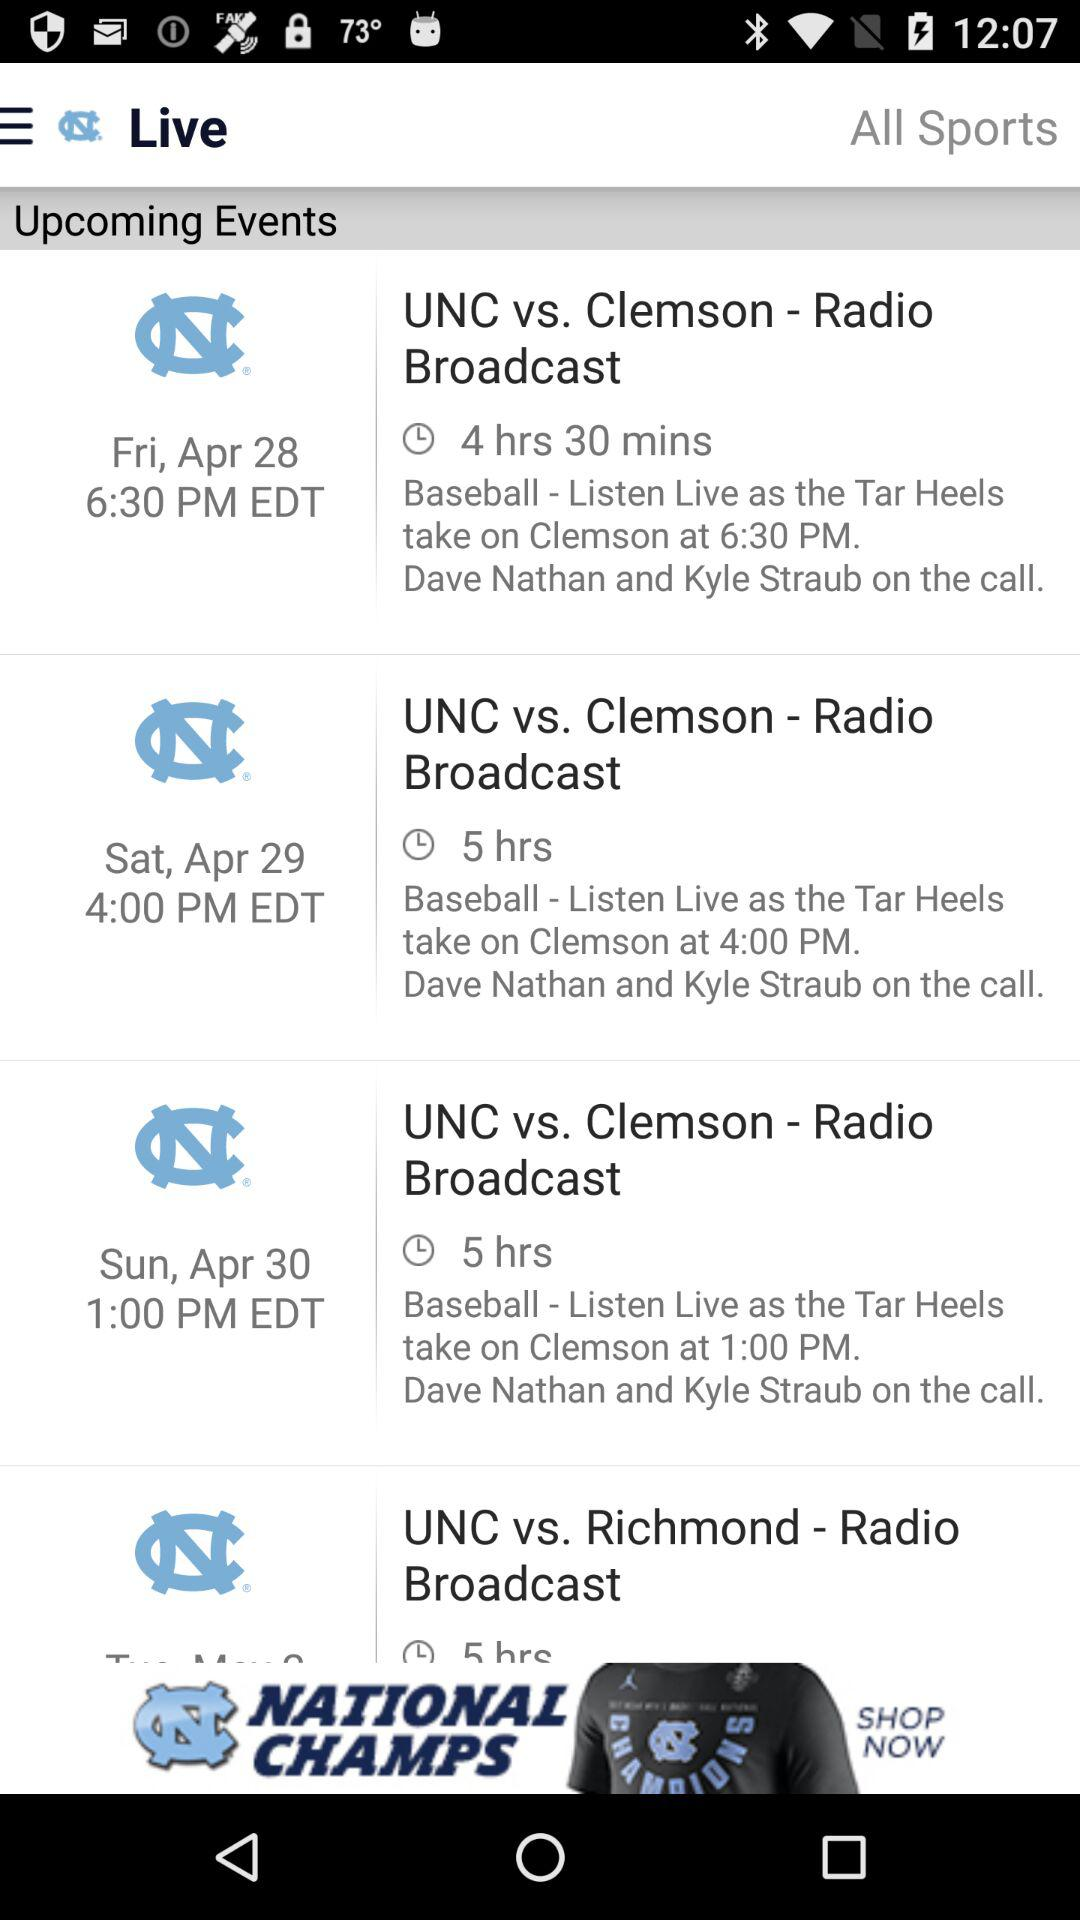What is the duration of the upcoming event named "UNC vs. Clemson - Radio Broadcast" that will be held on April 29th at 4 PM? The duration of the upcoming event named "UNC vs. Clemson - Radio Broadcast" that will be held on April 29th at 4 PM is 5 hours. 